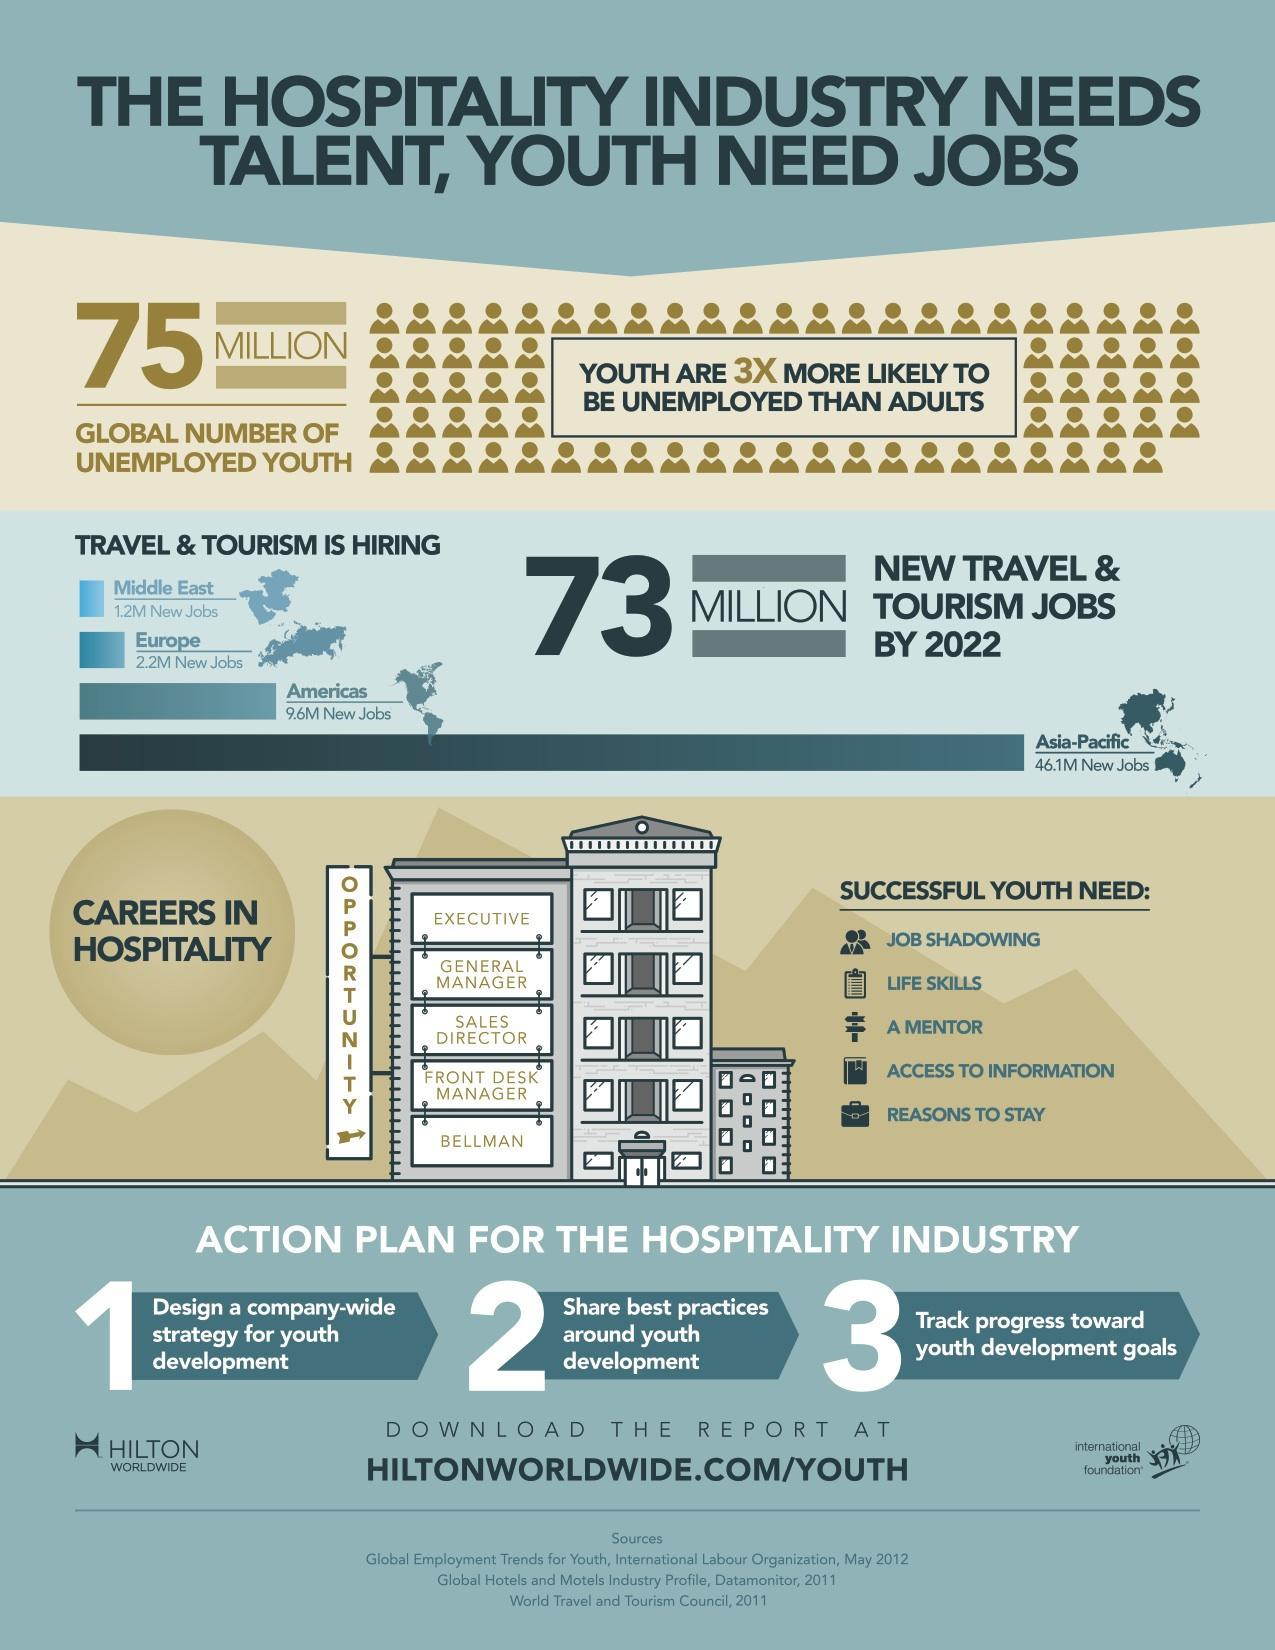What is the total number of new jobs available in travel and tourism?
Answer the question with a short phrase. 59.1 Million jobs How many career opportunities are available in hospitality industry? 5 